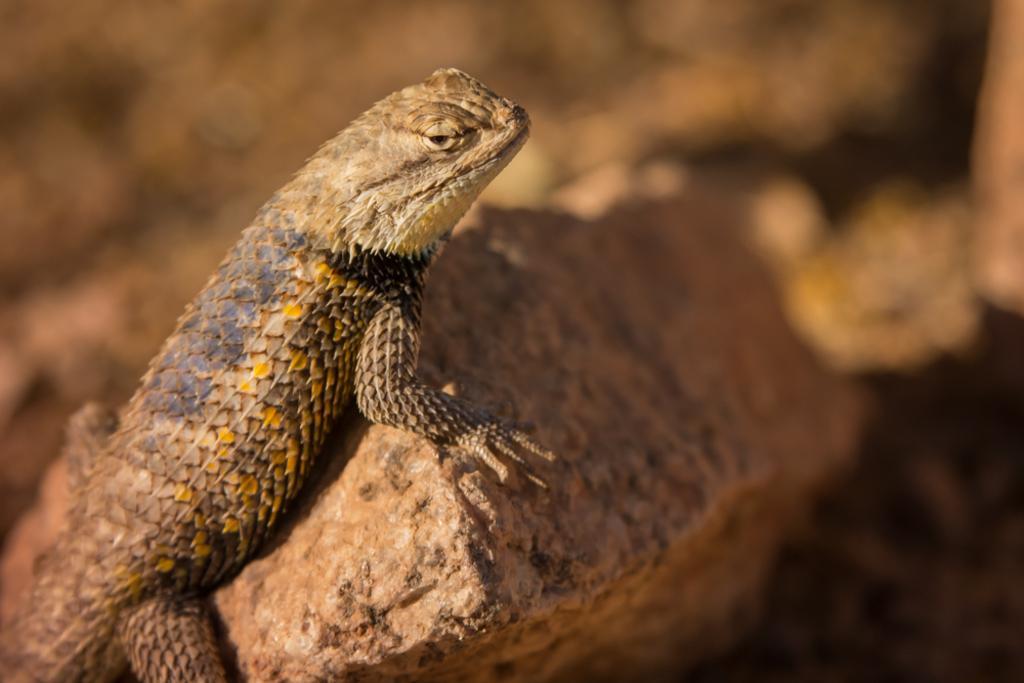Could you give a brief overview of what you see in this image? In this picture there is a reptile on the stone. At the back the image is blurry. 